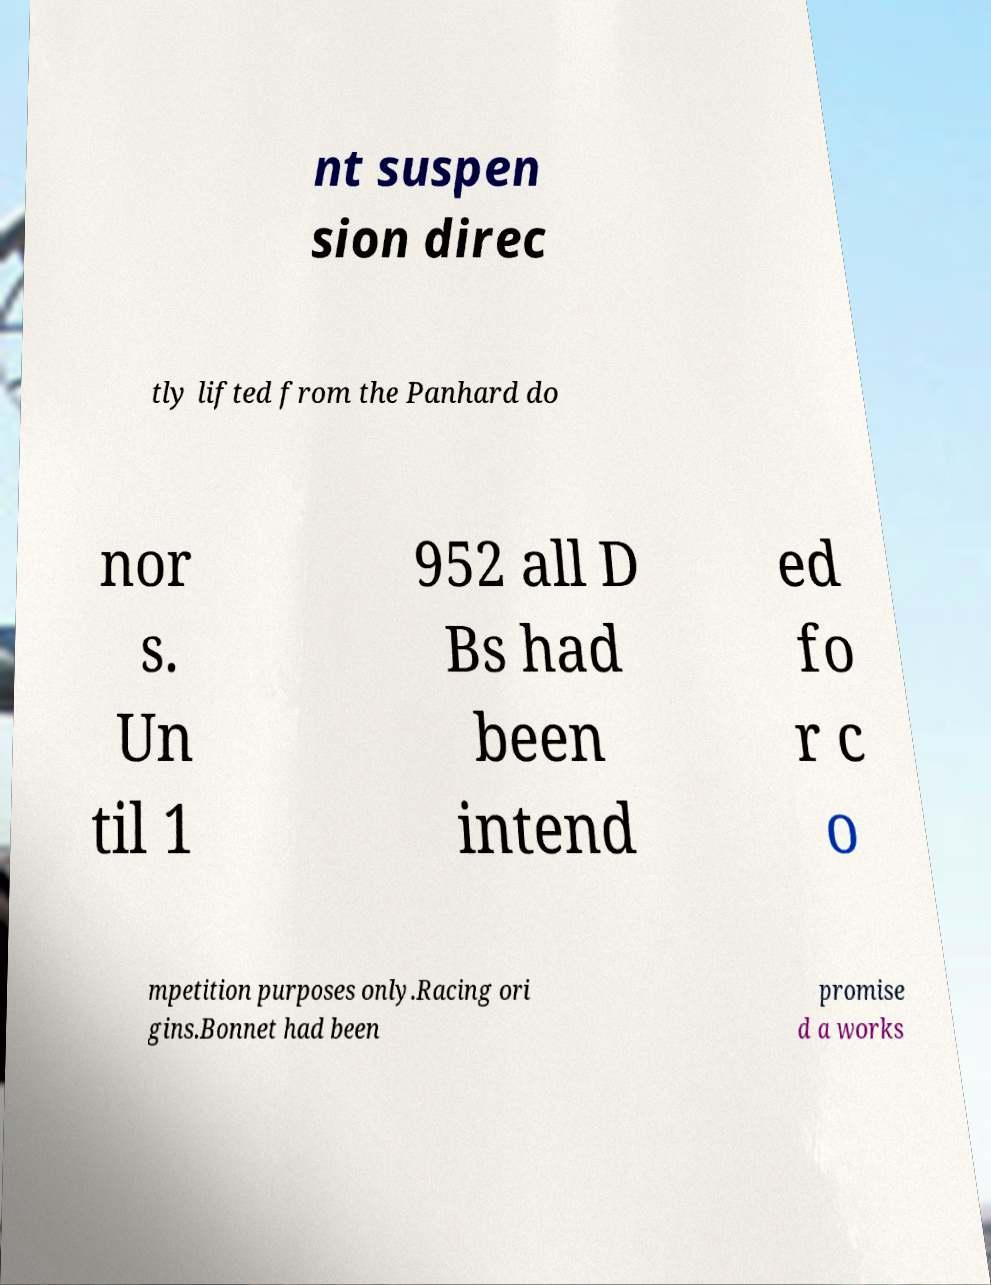There's text embedded in this image that I need extracted. Can you transcribe it verbatim? nt suspen sion direc tly lifted from the Panhard do nor s. Un til 1 952 all D Bs had been intend ed fo r c o mpetition purposes only.Racing ori gins.Bonnet had been promise d a works 